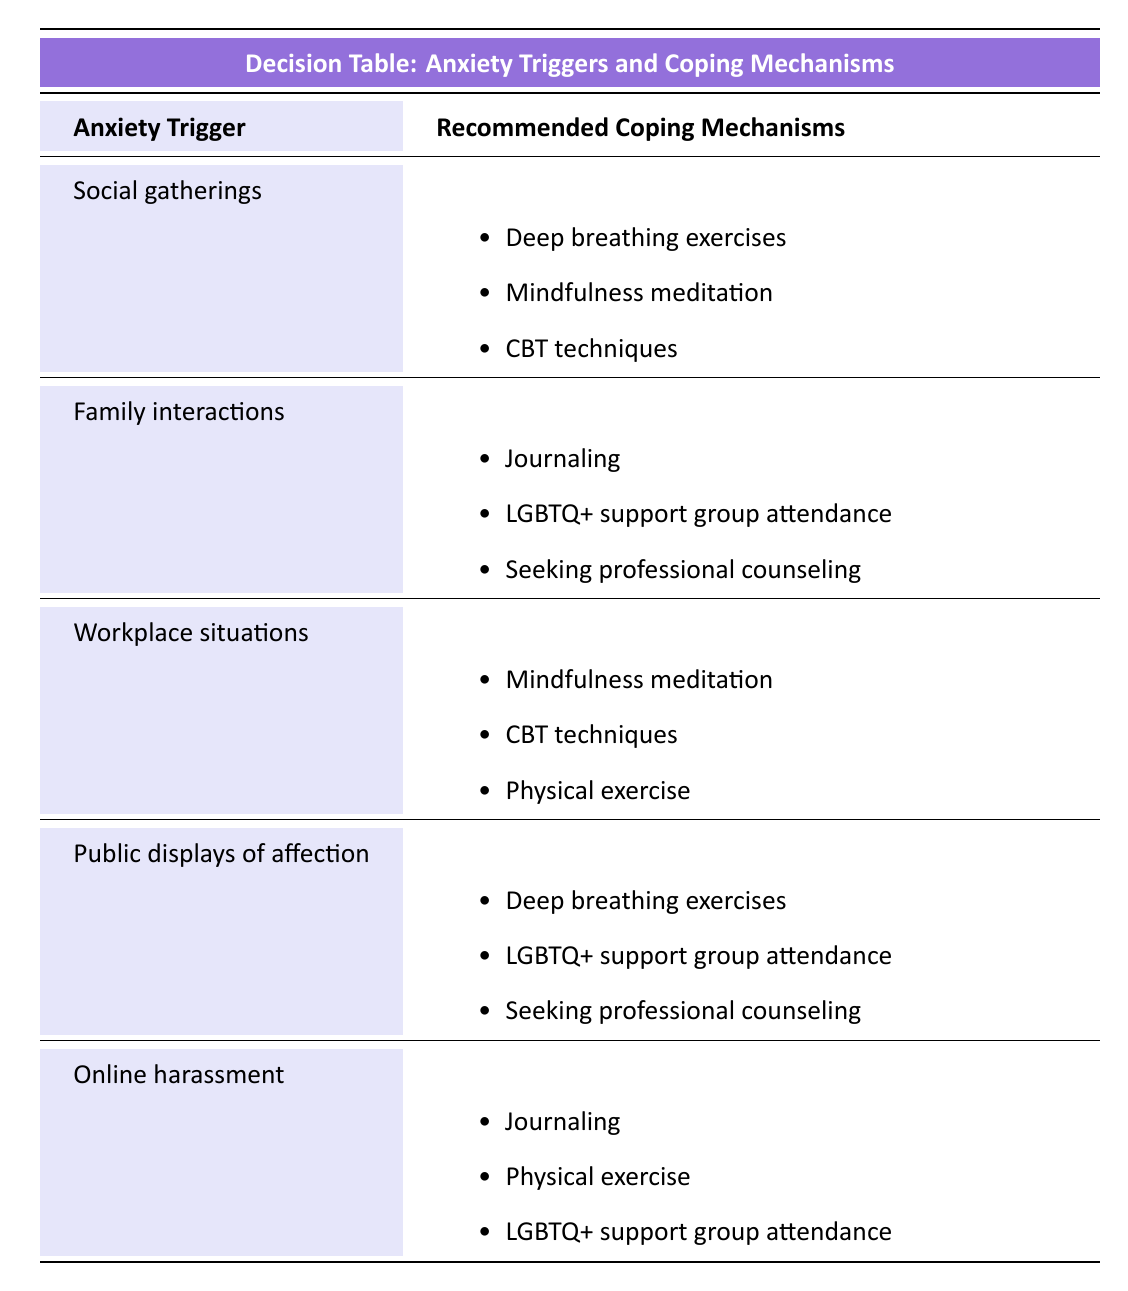What coping mechanisms are recommended for social gatherings? The table indicates that for the trigger "Social gatherings," the recommended coping mechanisms are "Deep breathing exercises," "Mindfulness meditation," and "CBT techniques."
Answer: Deep breathing exercises, mindfulness meditation, CBT techniques What are two recommended coping mechanisms for family interactions? The table lists the coping mechanisms for "Family interactions" as "Journaling," "LGBTQ+ support group attendance," and "Seeking professional counseling." Hence, picking any two from this list fits the question.
Answer: Journaling, LGBTQ+ support group attendance True or false: Physical exercise is recommended for online harassment. According to the table, for the trigger "Online harassment," one of the recommended coping mechanisms is "Physical exercise." Therefore, the statement is true.
Answer: True How many recommended coping mechanisms are there for workplace situations? The table shows that there are three recommended coping mechanisms for the trigger "Workplace situations": "Mindfulness meditation," "CBT techniques," and "Physical exercise." Therefore, counting these gives the total.
Answer: Three What is the largest number of coping mechanisms recommended for any single anxiety trigger? By analyzing the table, each trigger has three coping mechanisms recommended. Thus, the maximum number across all triggers is three, as no trigger has more than that.
Answer: Three Which coping mechanisms are common for public displays of affection and family interactions? Both "LGBTQ+ support group attendance" and "Seeking professional counseling" appear in the lists for "Public displays of affection" and "Family interactions." Thus, these are the common coping mechanisms.
Answer: LGBTQ+ support group attendance, seeking professional counseling What is the relationship between the recommended coping mechanisms for social gatherings and workplace situations? The coping mechanisms for "Social gatherings" include "Deep breathing exercises," "Mindfulness meditation," and "CBT techniques." For "Workplace situations," they include "Mindfulness meditation," "CBT techniques," and "Physical exercise." Both include "Mindfulness meditation" and "CBT techniques," illustrating overlap in recommendations.
Answer: Mindfulness meditation, CBT techniques If someone experiences severe anxiety about social gatherings, which coping mechanisms should they consider? The table doesn't specify the intensity of anxiety in relation to coping mechanisms; however, individuals experiencing severe anxiety may want to consider all options listed for social gatherings: "Deep breathing exercises," "Mindfulness meditation," and "CBT techniques," as these can be applied regardless of intensity.
Answer: Deep breathing exercises, mindfulness meditation, CBT techniques 